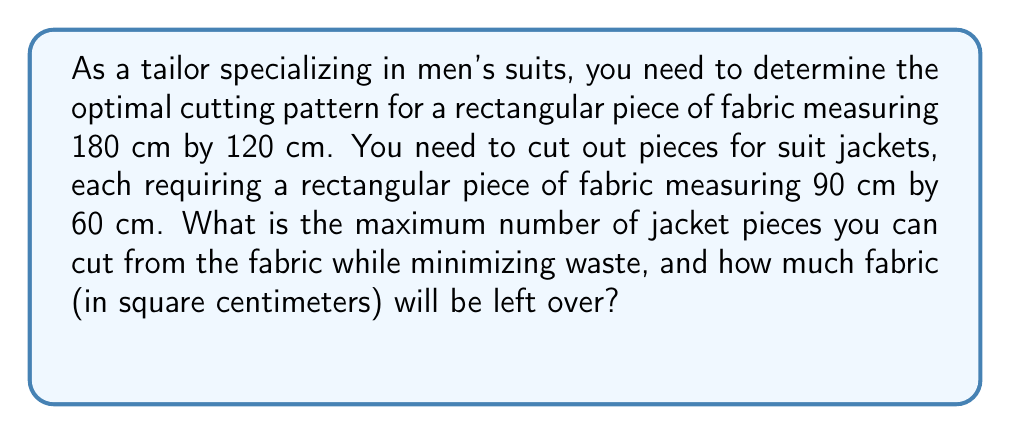Provide a solution to this math problem. To solve this problem, we need to follow these steps:

1) First, let's calculate the area of the entire fabric:
   $$A_{total} = 180 \text{ cm} \times 120 \text{ cm} = 21,600 \text{ cm}^2$$

2) Now, let's calculate the area required for each jacket piece:
   $$A_{jacket} = 90 \text{ cm} \times 60 \text{ cm} = 5,400 \text{ cm}^2$$

3) To determine the maximum number of jacket pieces, we need to consider how they can be arranged on the fabric. We can fit:
   - 2 pieces along the length (180 cm ÷ 90 cm = 2)
   - 2 pieces along the width (120 cm ÷ 60 cm = 2)

4) Therefore, the total number of jacket pieces that can be cut is:
   $$2 \times 2 = 4 \text{ pieces}$$

5) To calculate the area used by the jacket pieces:
   $$A_{used} = 4 \times 5,400 \text{ cm}^2 = 21,600 \text{ cm}^2$$

6) The leftover fabric (waste) is the difference between the total area and the used area:
   $$A_{waste} = A_{total} - A_{used} = 21,600 \text{ cm}^2 - 21,600 \text{ cm}^2 = 0 \text{ cm}^2$$

This cutting pattern results in no waste, which is the optimal solution for minimizing fabric waste.
Answer: The maximum number of jacket pieces that can be cut is 4, and there will be 0 cm² of fabric left over. 